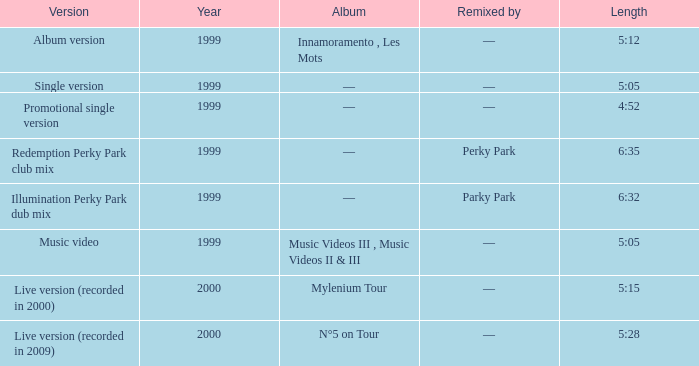What album is 5:15 long Live version (recorded in 2000). 